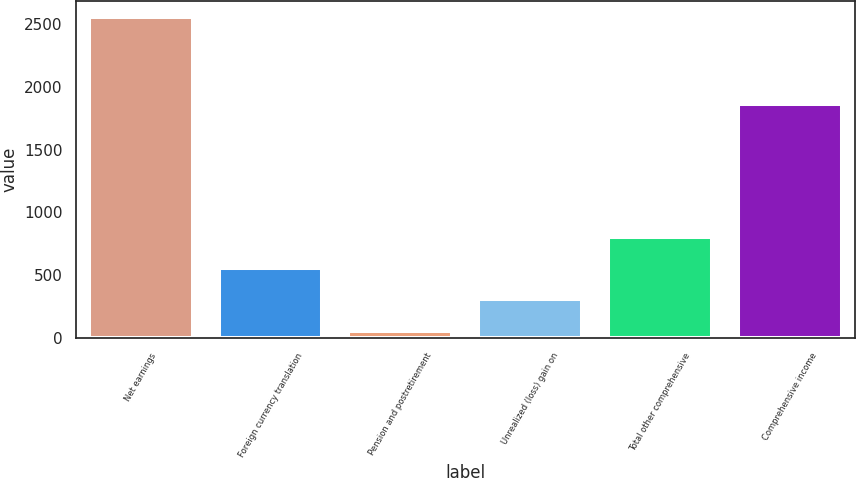<chart> <loc_0><loc_0><loc_500><loc_500><bar_chart><fcel>Net earnings<fcel>Foreign currency translation<fcel>Pension and postretirement<fcel>Unrealized (loss) gain on<fcel>Total other comprehensive<fcel>Comprehensive income<nl><fcel>2553.7<fcel>557.3<fcel>58.2<fcel>307.75<fcel>806.85<fcel>1863.4<nl></chart> 